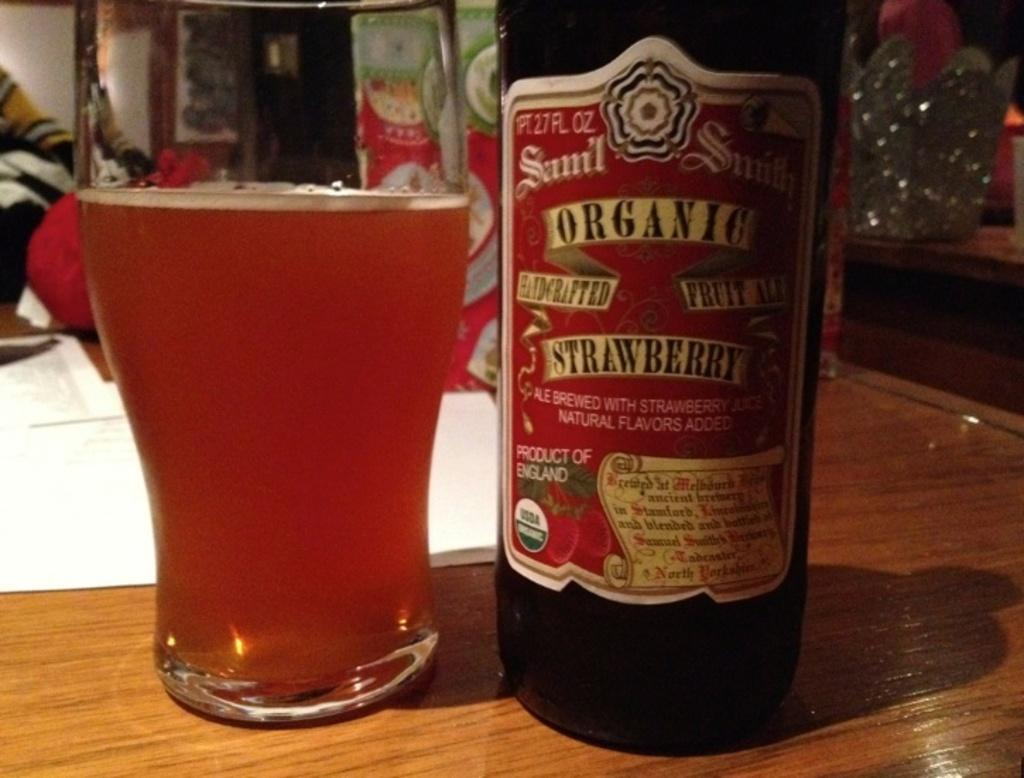<image>
Relay a brief, clear account of the picture shown. A bottle of Organic Strawberry Ale sits on a table 